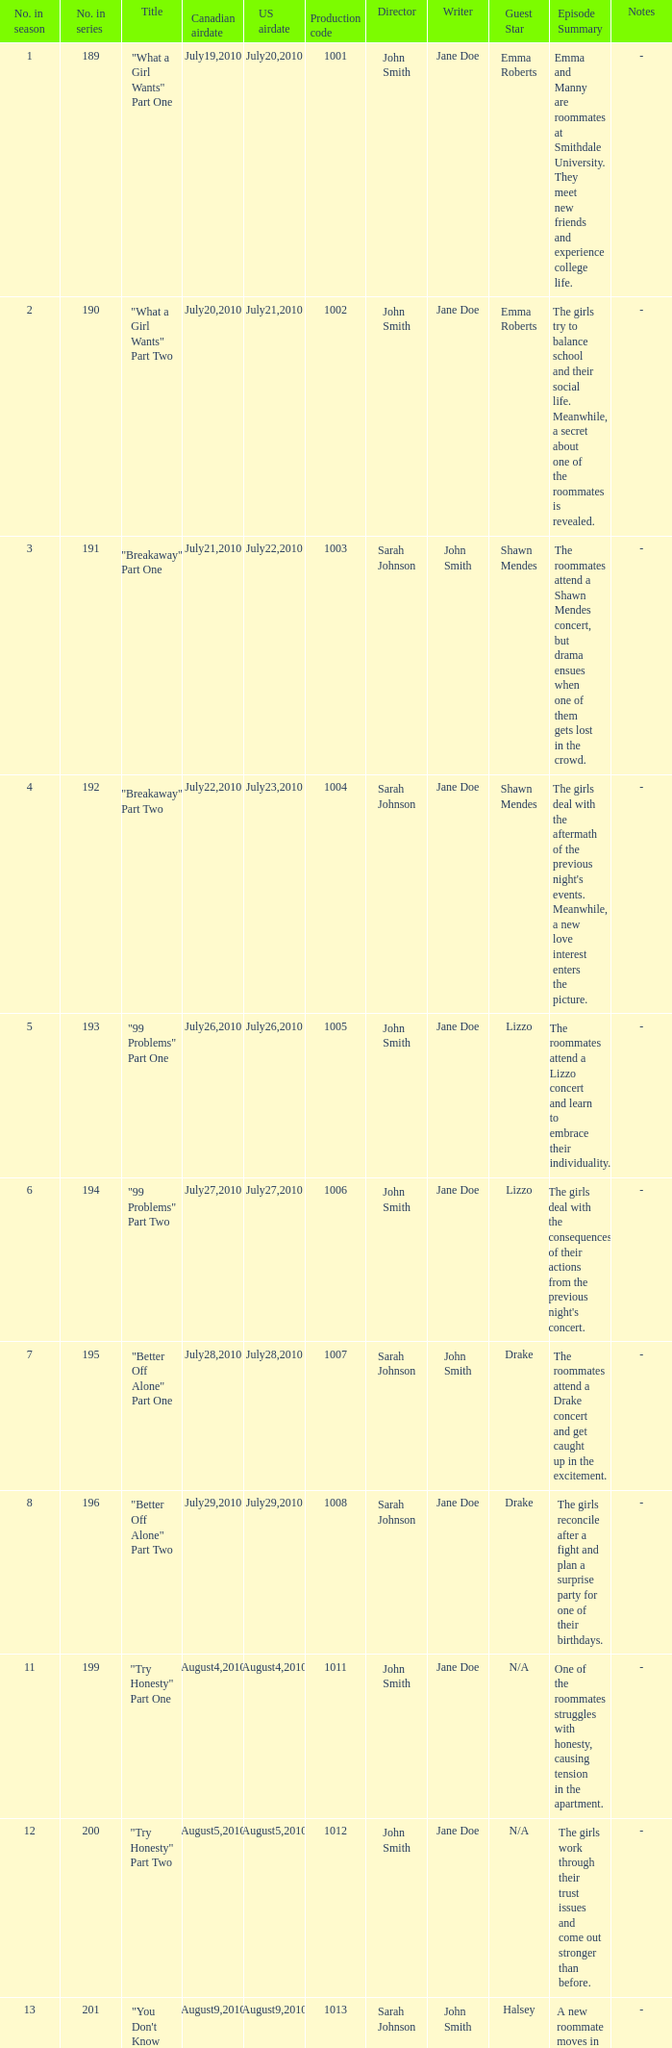How many titles had production code 1040? 1.0. 